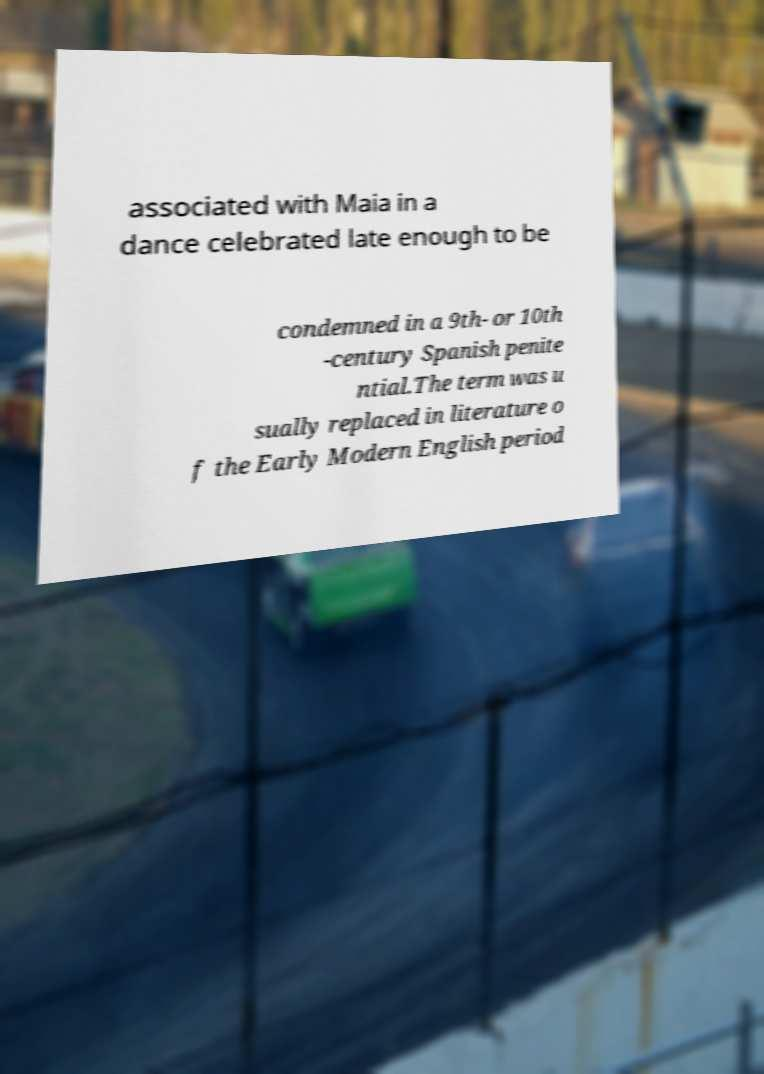Could you assist in decoding the text presented in this image and type it out clearly? associated with Maia in a dance celebrated late enough to be condemned in a 9th- or 10th -century Spanish penite ntial.The term was u sually replaced in literature o f the Early Modern English period 